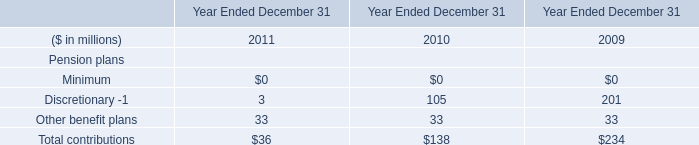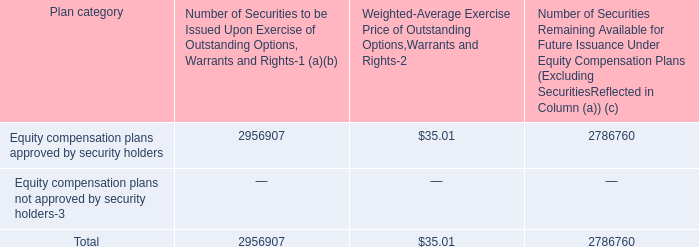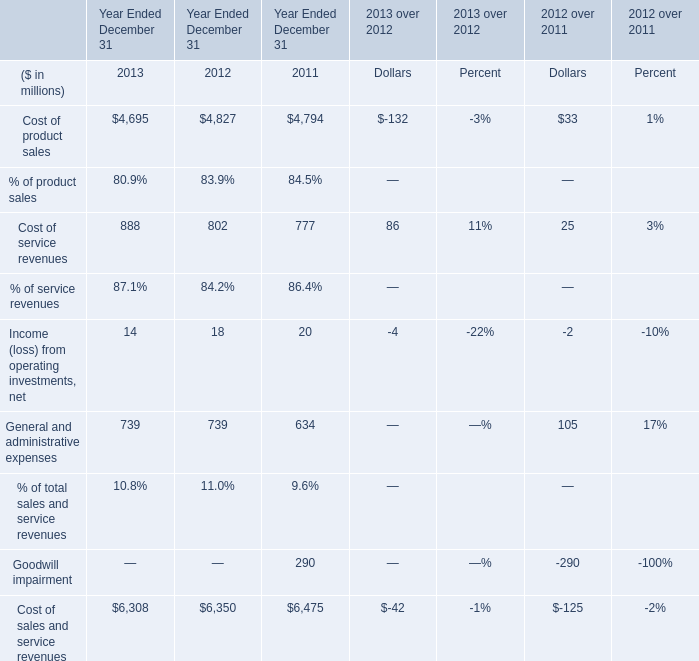Which year is Cost of sales and service revenues the lowest? 
Answer: 2013. 